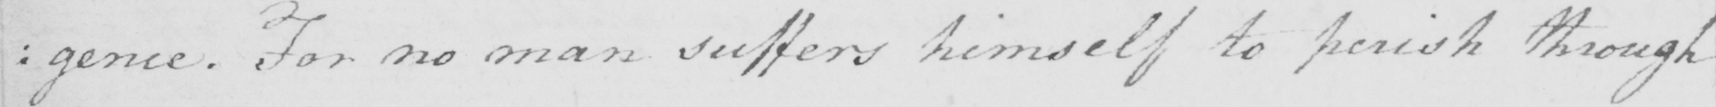Can you tell me what this handwritten text says? : gence . For no man suffers himself to perish through 